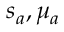<formula> <loc_0><loc_0><loc_500><loc_500>s _ { a } , \mu _ { a }</formula> 